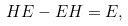Convert formula to latex. <formula><loc_0><loc_0><loc_500><loc_500>H E - E H = E ,</formula> 